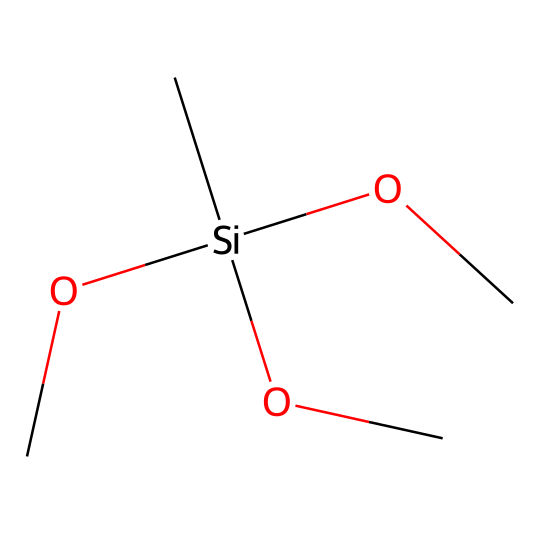What is the central atom in this organosilane? The molecule has a silicon atom (Si) at its center, indicated by the brackets, which connects to multiple substituents.
Answer: silicon How many methoxy groups are present in this chemical? The chemical structure shows three methoxy groups (each represented as -OCH3) attached to the silicon atom.
Answer: three What is the total number of atoms in this molecule? Counting all distinct atoms: 1 silicon, 3 carbon (from the methoxy groups), 9 hydrogen (3 from each methyl group), and 3 oxygen gives a total of 16 atoms.
Answer: sixteen What type of bond connects silicon to oxygen in this structure? The connection between silicon and oxygen in this organosilane is a covalent bond, as silicon forms strong bonds with oxygen in organosilanes.
Answer: covalent Can this compound be classified as a branched organosilane? Yes, the presence of multiple methoxy groups attached to the silicon atom indicates that this is a branched organosilane structure.
Answer: yes 